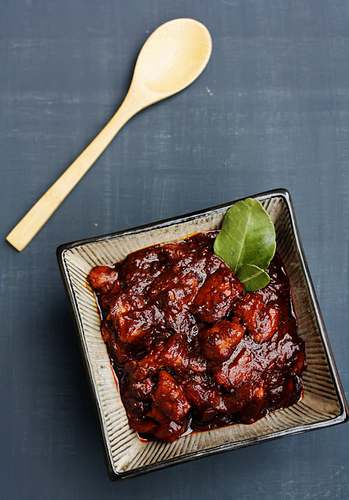<image>
Can you confirm if the food is on the table? Yes. Looking at the image, I can see the food is positioned on top of the table, with the table providing support. Where is the spoon in relation to the leaf? Is it to the left of the leaf? Yes. From this viewpoint, the spoon is positioned to the left side relative to the leaf. 